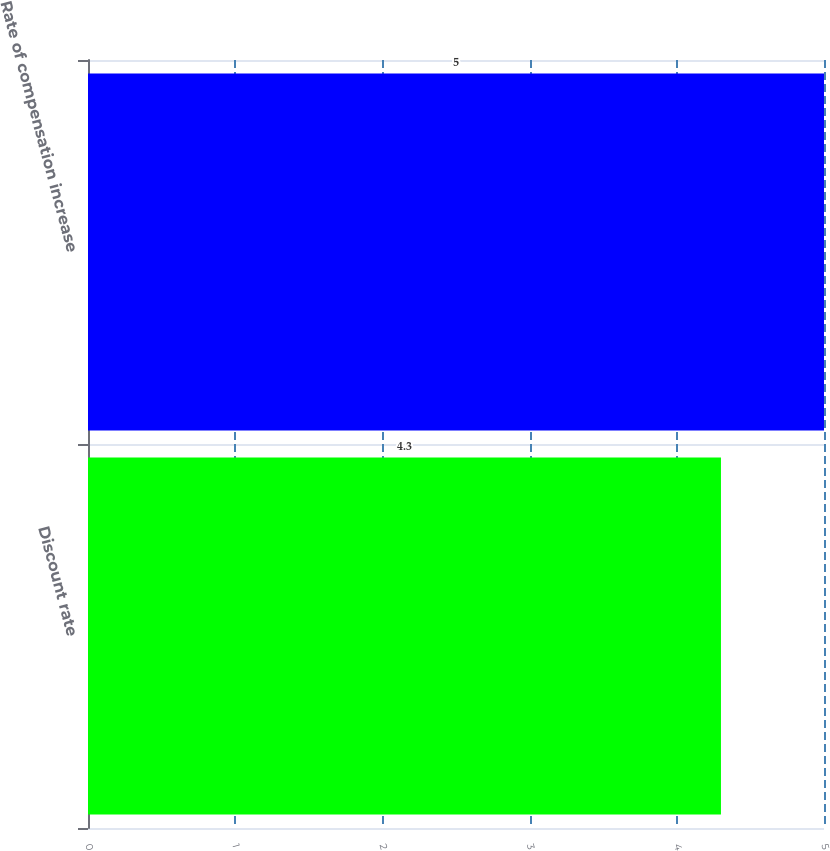Convert chart. <chart><loc_0><loc_0><loc_500><loc_500><bar_chart><fcel>Discount rate<fcel>Rate of compensation increase<nl><fcel>4.3<fcel>5<nl></chart> 